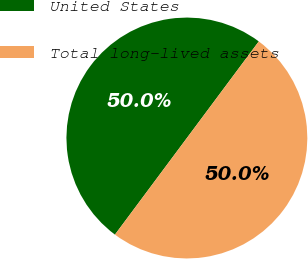Convert chart to OTSL. <chart><loc_0><loc_0><loc_500><loc_500><pie_chart><fcel>United States<fcel>Total long-lived assets<nl><fcel>50.0%<fcel>50.0%<nl></chart> 